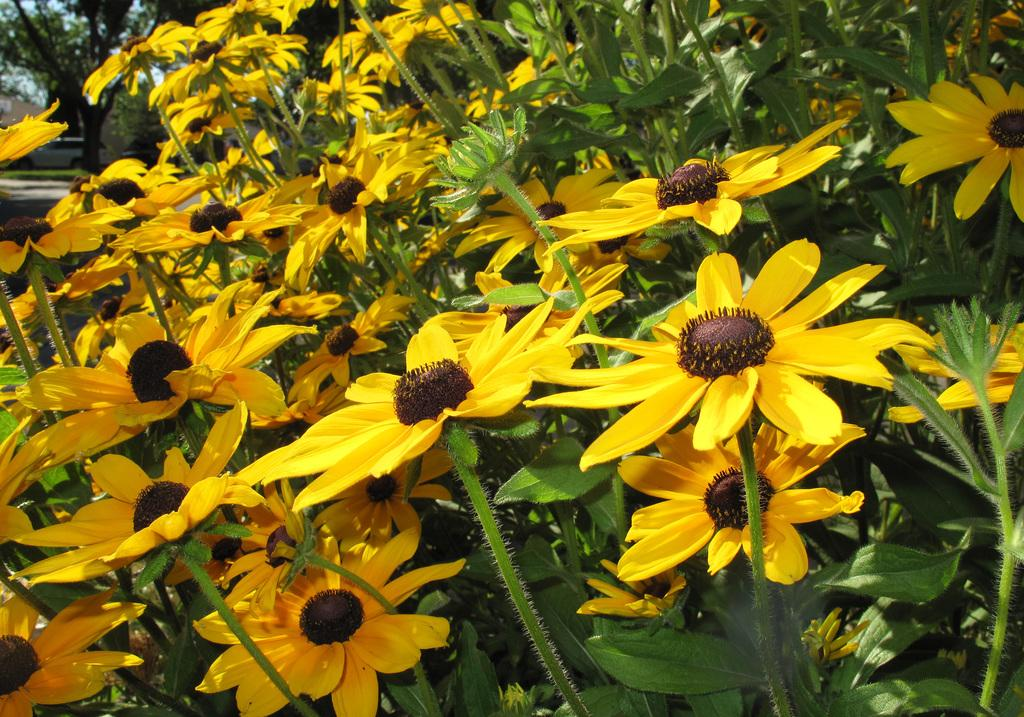What is the main subject in the foreground of the picture? There are many flowers in the foreground of the picture. What are the flowers situated on? The flowers are on plants. What can be seen in the background of the image? There are trees, a path, and grass visible in the background of the image. What type of pen can be seen in the basket in the image? There is no pen or basket present in the image. 